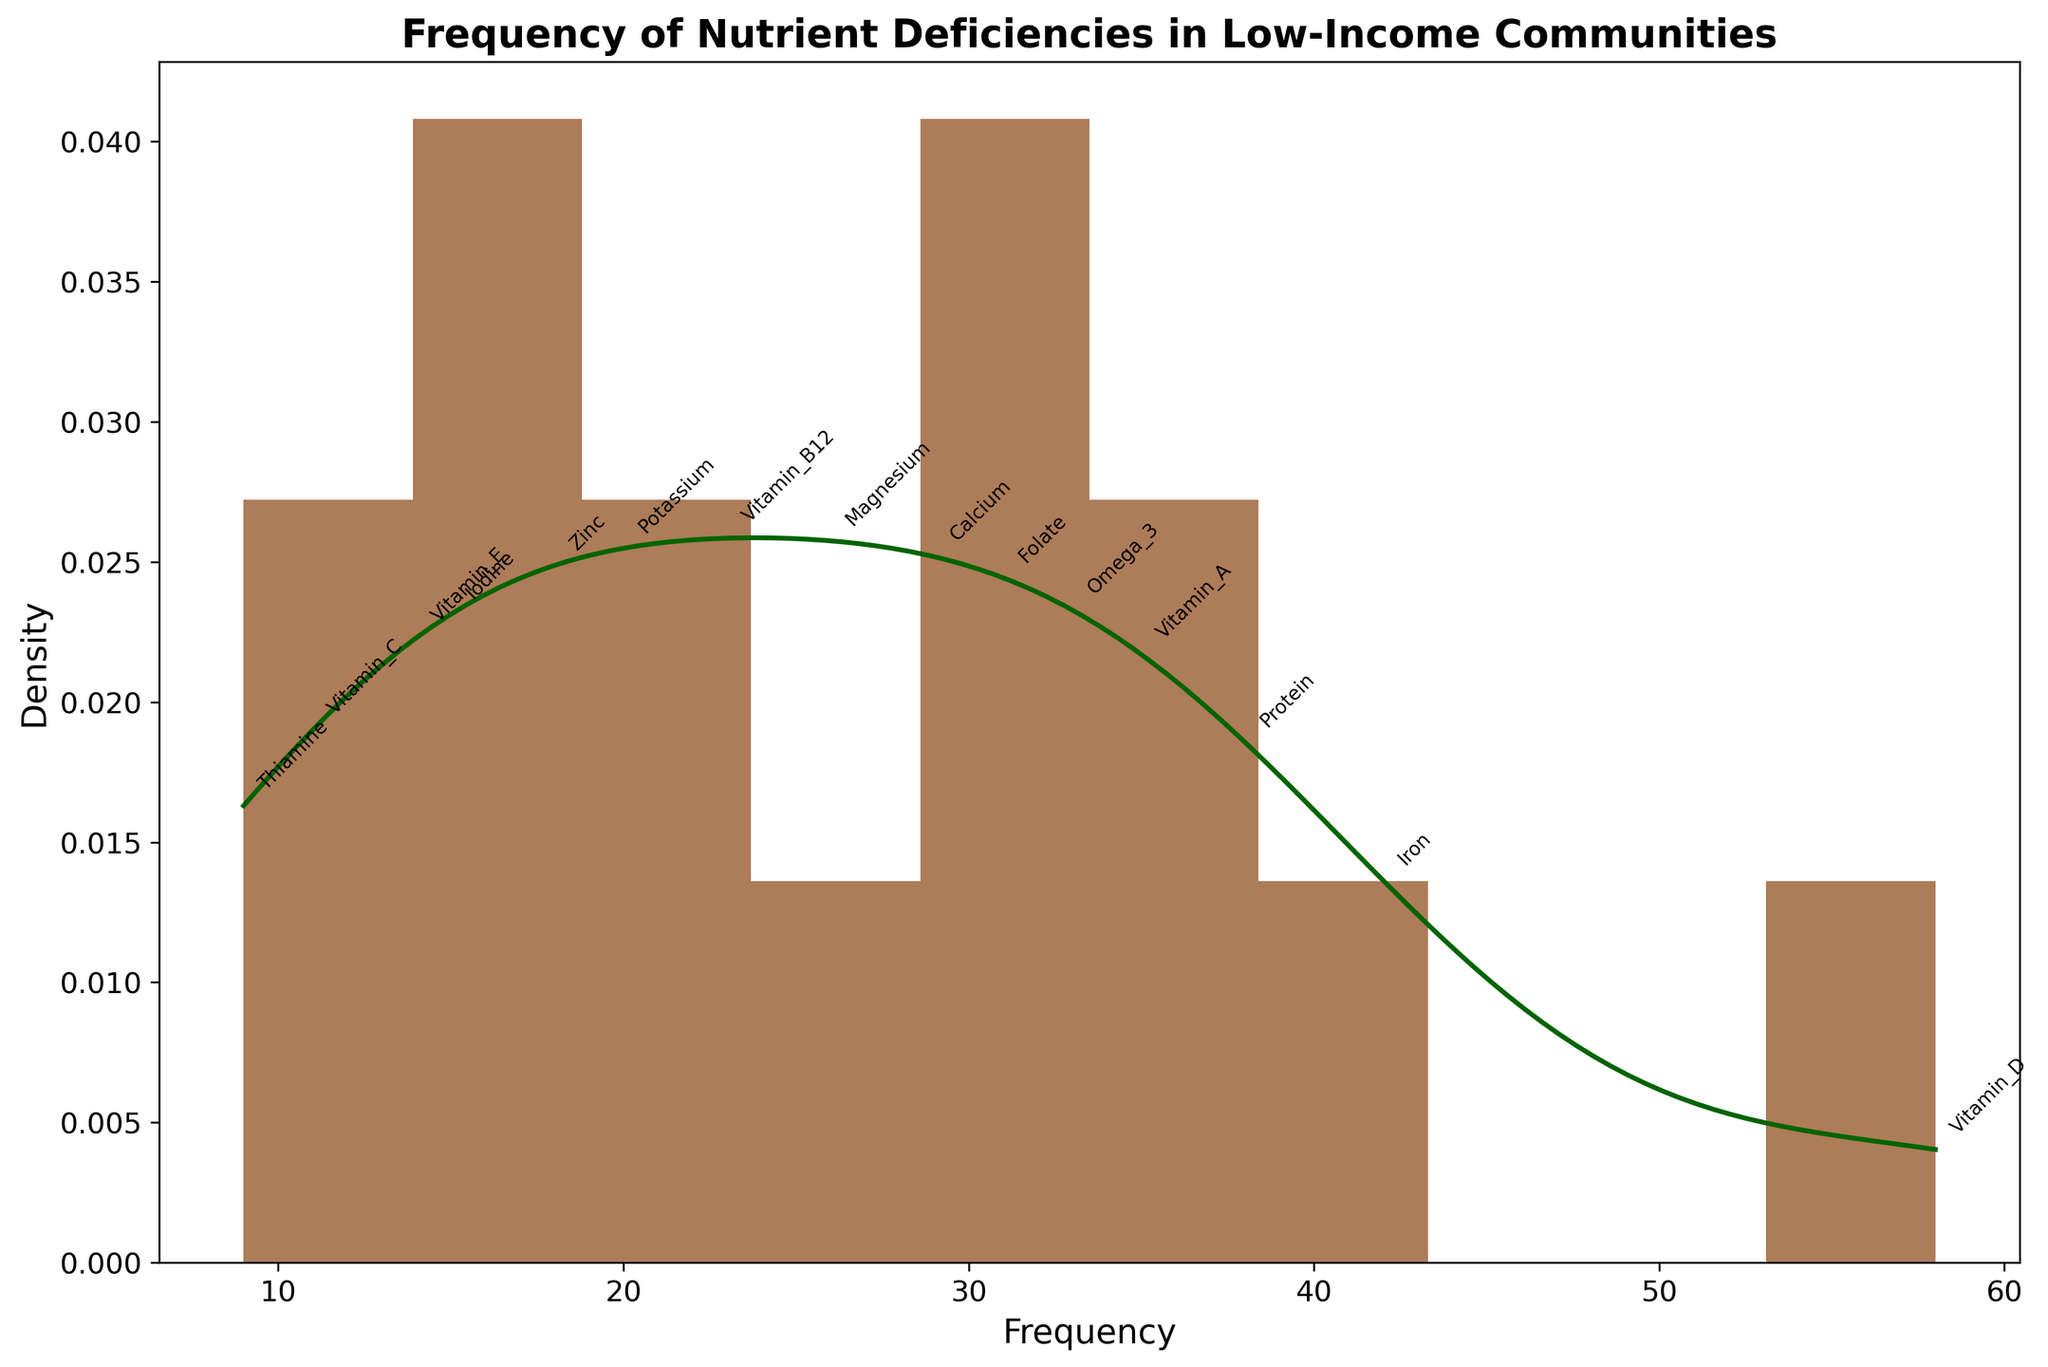What is the title of the plot? The title is typically located at the top of the plot and it's intended to describe the overall content or purpose of the graph. In this case, the title is "Frequency of Nutrient Deficiencies in Low-Income Communities".
Answer: Frequency of Nutrient Deficiencies in Low-Income Communities How many bins are used in the histogram? We can count the number of vertical bars to determine how many bins are in the histogram. According to this plot, there are 10 bins.
Answer: 10 Which nutrient has the highest frequency of deficiency? By looking at the topmost point of the histogram and reading the associated nutrient, we can determine that Vitamin D, with a frequency of 58, has the highest frequency of deficiency.
Answer: Vitamin D What is the range of the x-axis in the plot? The x-axis range can be determined by identifying the minimum and maximum values of nutrient frequencies displayed on the plot, which range from 9 (Thiamine) to 58 (Vitamin D).
Answer: 9 to 58 Which nutrient has the lowest deficiency frequency? By identifying the bar at the lowest point on the histogram and checking the corresponding annotation, we can see that Thiamine, with a frequency of 9, has the lowest deficiency frequency.
Answer: Thiamine What can be inferred about the density of nutrient deficiencies around the frequency of 35? By observing the KDE curve, we can see that it has a peak around the frequency of 35, suggesting that the density of nutrient deficiencies is relatively high around this frequency compared to others.
Answer: High density What is the frequency range with the highest density of nutrient deficiencies? The KDE curve reaches its peaks at certain frequency ranges, indicating maximum density. It appears that the highest density is around the mid to high 30s and low 40s.
Answer: Mid 30s to low 40s How many nutrients have a frequency higher than 30 but less than 40? We count the nutrients that fall within the given frequency range by referring to the histogram bars and their labels. These are Iron, Folate, Protein, and Omega-3, making a total of 4 nutrients.
Answer: 4 What is the median frequency of nutrient deficiencies? To find the median, we sort the frequencies and find the middle value in the ordered list. The sorted list is [9, 11, 14, 15, 18, 20, 23, 26, 29, 31, 33, 35, 38, 42, 58]. The median value is the 8th value in the ordered list, which is 26.
Answer: 26 